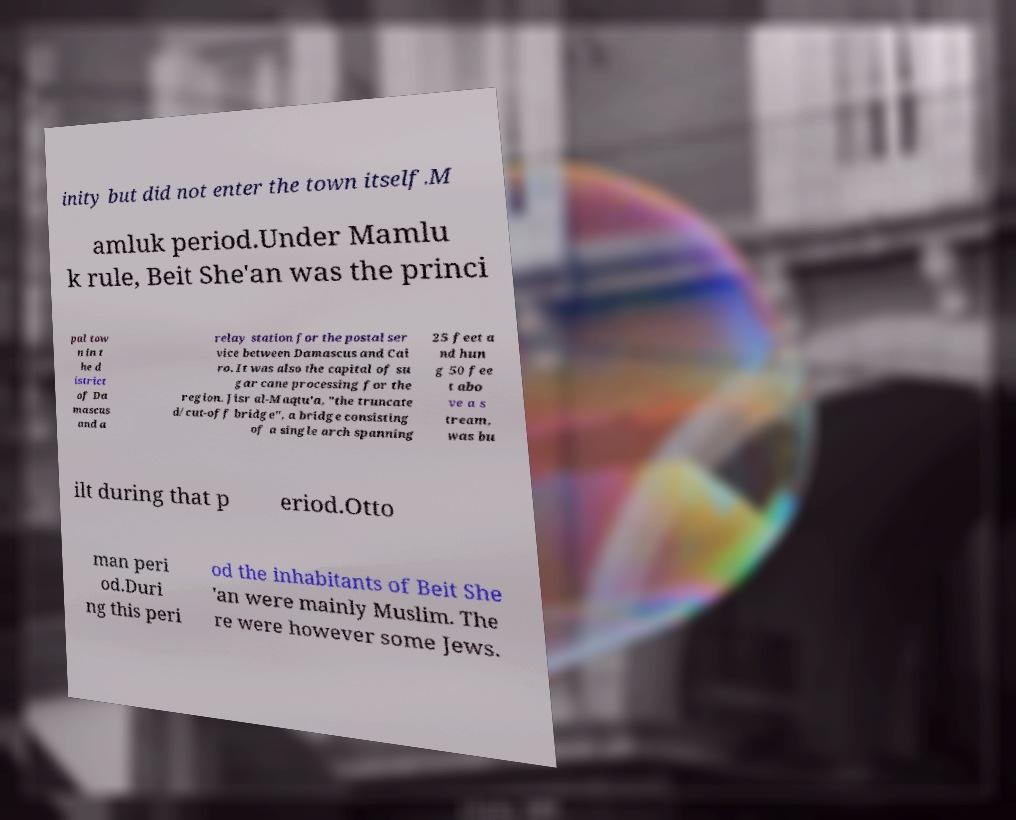Could you assist in decoding the text presented in this image and type it out clearly? inity but did not enter the town itself.M amluk period.Under Mamlu k rule, Beit She'an was the princi pal tow n in t he d istrict of Da mascus and a relay station for the postal ser vice between Damascus and Cai ro. It was also the capital of su gar cane processing for the region. Jisr al-Maqtu'a, "the truncate d/cut-off bridge", a bridge consisting of a single arch spanning 25 feet a nd hun g 50 fee t abo ve a s tream, was bu ilt during that p eriod.Otto man peri od.Duri ng this peri od the inhabitants of Beit She 'an were mainly Muslim. The re were however some Jews. 